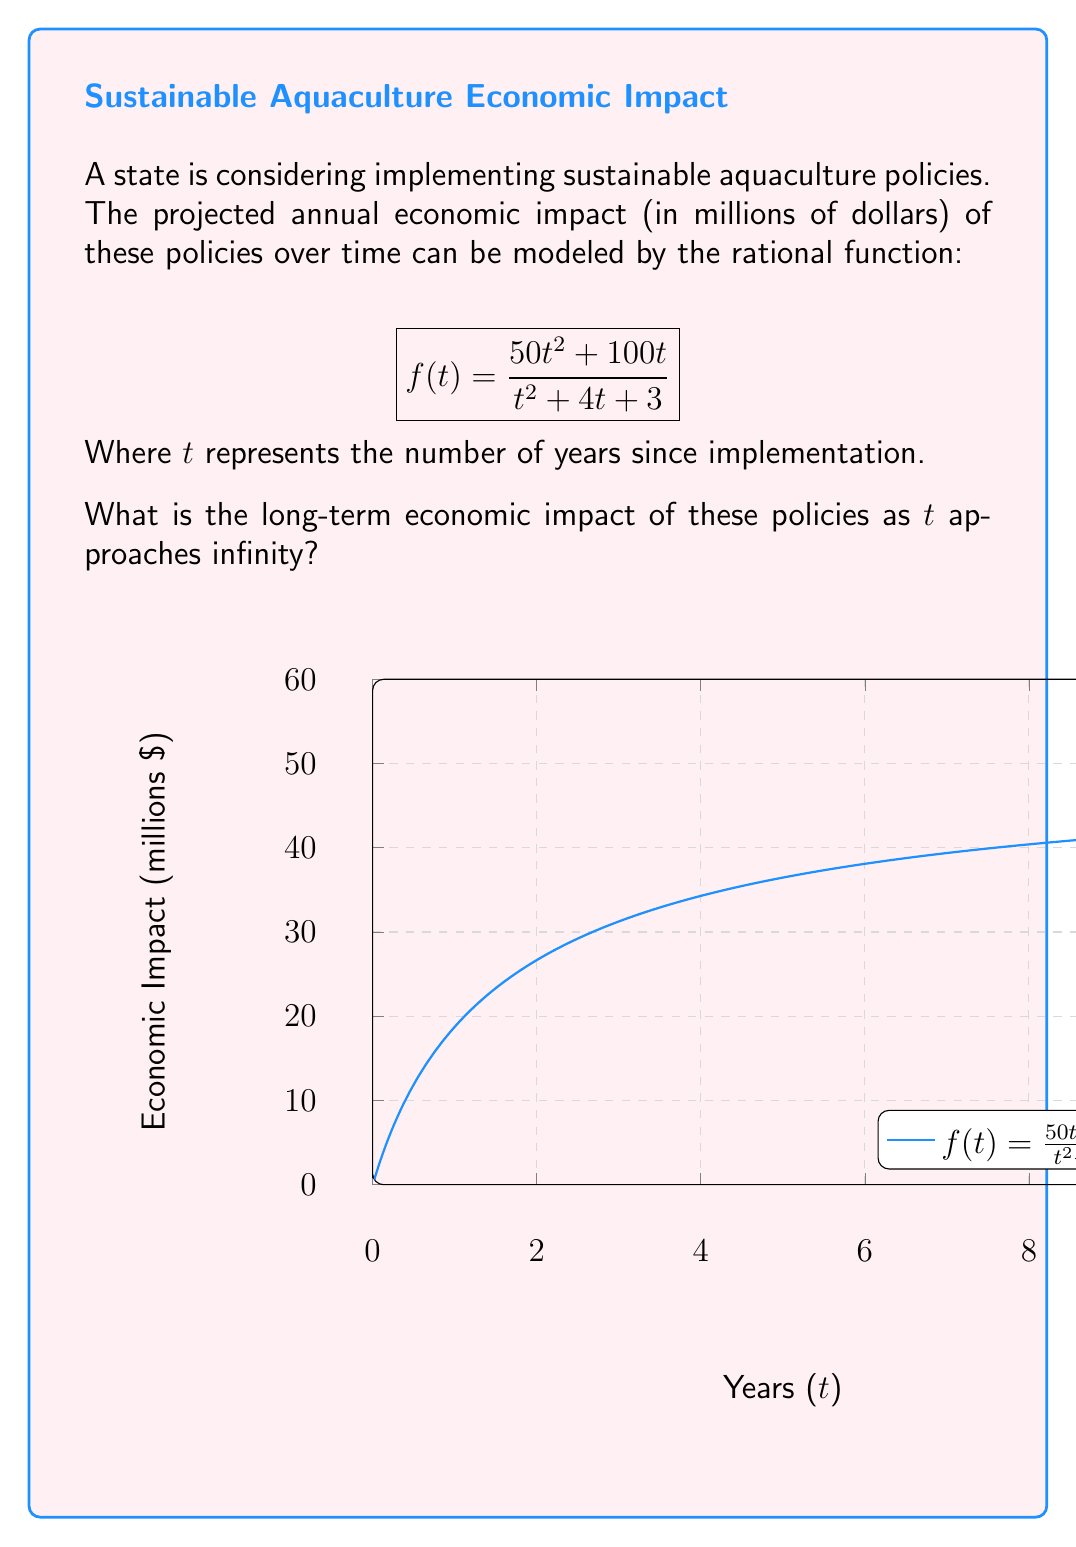Help me with this question. To find the long-term economic impact, we need to calculate the limit of $f(t)$ as $t$ approaches infinity. Let's follow these steps:

1) First, let's examine the rational function:
   $$f(t) = \frac{50t^2 + 100t}{t^2 + 4t + 3}$$

2) To find the limit as $t$ approaches infinity, we look at the highest degree terms in the numerator and denominator:
   $$\lim_{t\to\infty} f(t) = \lim_{t\to\infty} \frac{50t^2 + 100t}{t^2 + 4t + 3}$$

3) The highest degree in both numerator and denominator is 2. In this case, we divide both the numerator and denominator by $t^2$:

   $$\lim_{t\to\infty} \frac{50t^2 + 100t}{t^2 + 4t + 3} = \lim_{t\to\infty} \frac{50 + 100/t}{1 + 4/t + 3/t^2}$$

4) As $t$ approaches infinity, $1/t$ and $1/t^2$ approach 0:

   $$\lim_{t\to\infty} \frac{50 + 100/t}{1 + 4/t + 3/t^2} = \frac{50 + 0}{1 + 0 + 0} = 50$$

5) Therefore, the long-term economic impact of the sustainable aquaculture policies is $50 million per year.
Answer: $50 million per year 